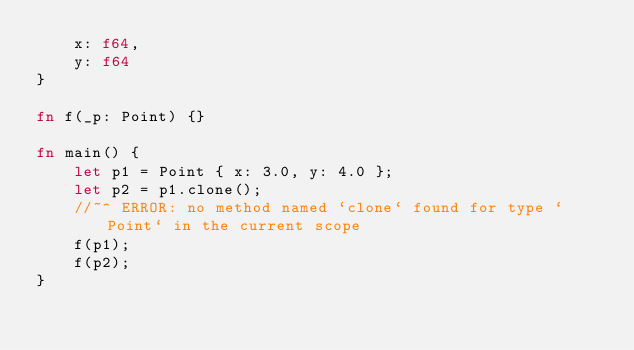<code> <loc_0><loc_0><loc_500><loc_500><_Rust_>    x: f64,
    y: f64
}

fn f(_p: Point) {}

fn main() {
    let p1 = Point { x: 3.0, y: 4.0 };
    let p2 = p1.clone();
    //~^ ERROR: no method named `clone` found for type `Point` in the current scope
    f(p1);
    f(p2);
}
</code> 